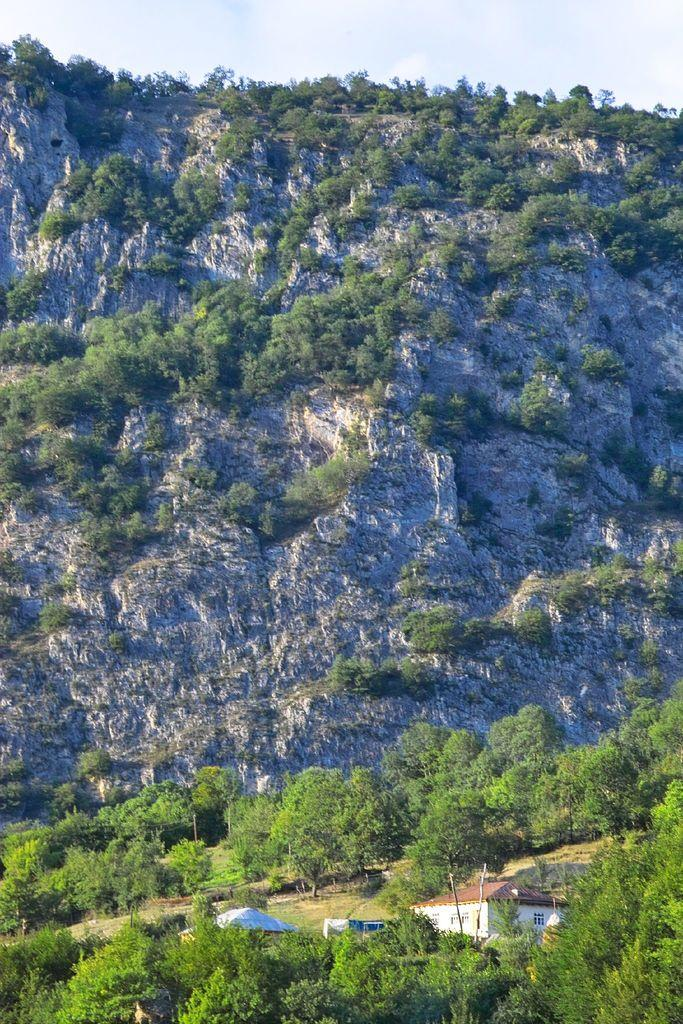What type of geological formation is in the image? There is a stone mountain in the image. What type of vegetation can be seen in the image? There are trees in the image. What structures are visible at the bottom of the image? There are buildings visible at the bottom of the image. What is visible at the top of the image? The sky is visible at the top of the image. What can be seen in the sky? Clouds are present in the sky. What type of snake can be seen slithering on the stone mountain in the image? There is no snake present in the image; it only features a stone mountain, trees, buildings, and a sky with clouds. 